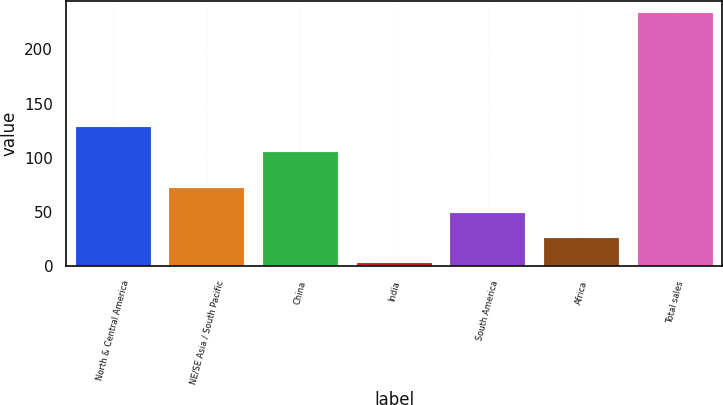Convert chart. <chart><loc_0><loc_0><loc_500><loc_500><bar_chart><fcel>North & Central America<fcel>NE/SE Asia / South Pacific<fcel>China<fcel>India<fcel>South America<fcel>Africa<fcel>Total sales<nl><fcel>128<fcel>72<fcel>105<fcel>3<fcel>49<fcel>26<fcel>233<nl></chart> 